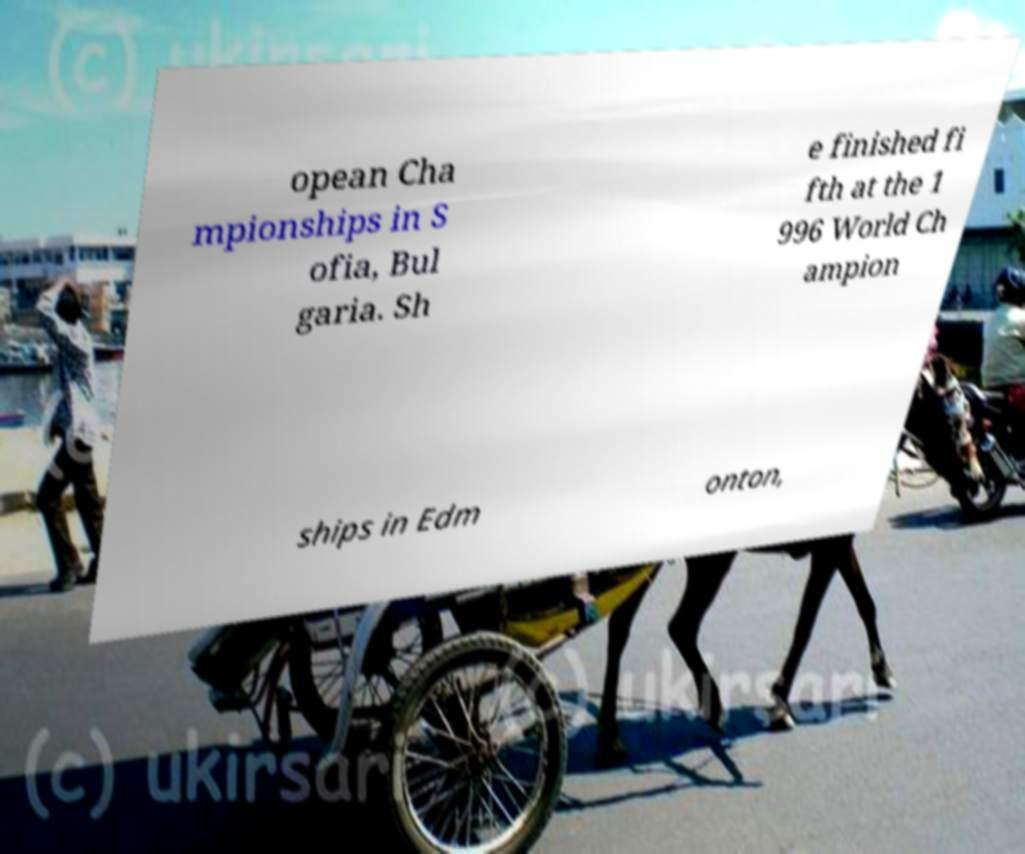What messages or text are displayed in this image? I need them in a readable, typed format. opean Cha mpionships in S ofia, Bul garia. Sh e finished fi fth at the 1 996 World Ch ampion ships in Edm onton, 